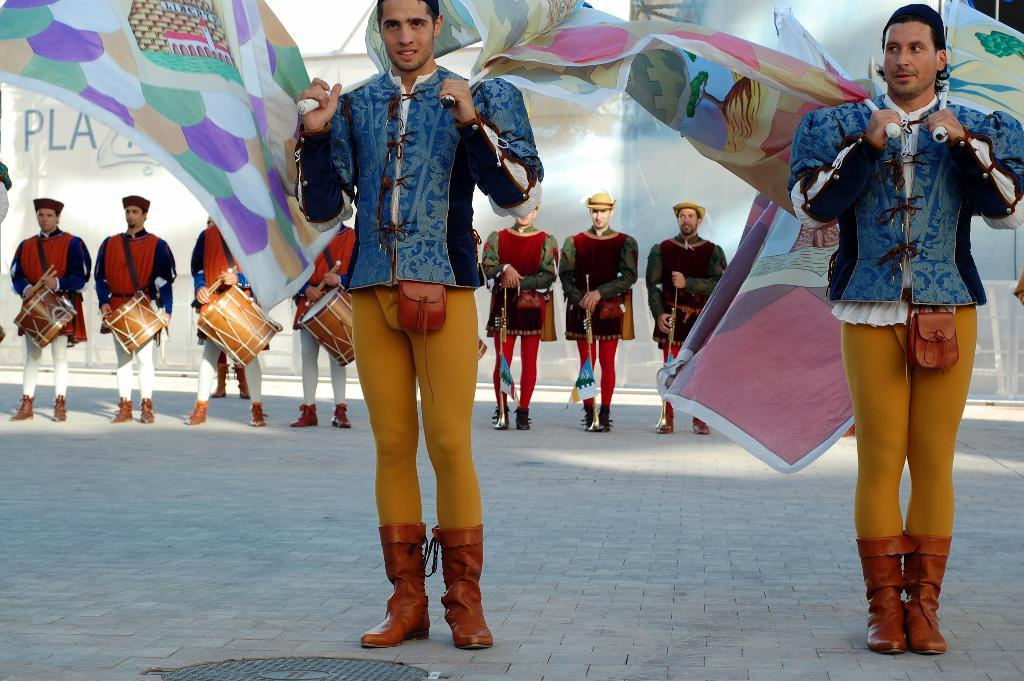How many people are present in the image? There are two persons standing in the image. What are the two persons holding? The two persons are holding flags. What can be seen in the background of the image? There is a group of people in the background of the image. What are the people in the background holding? The people in the background are holding musical instruments. What type of shade is being used to protect the oil in the image? There is no shade or oil present in the image; it features two persons holding flags and a group of people holding musical instruments in the background. 